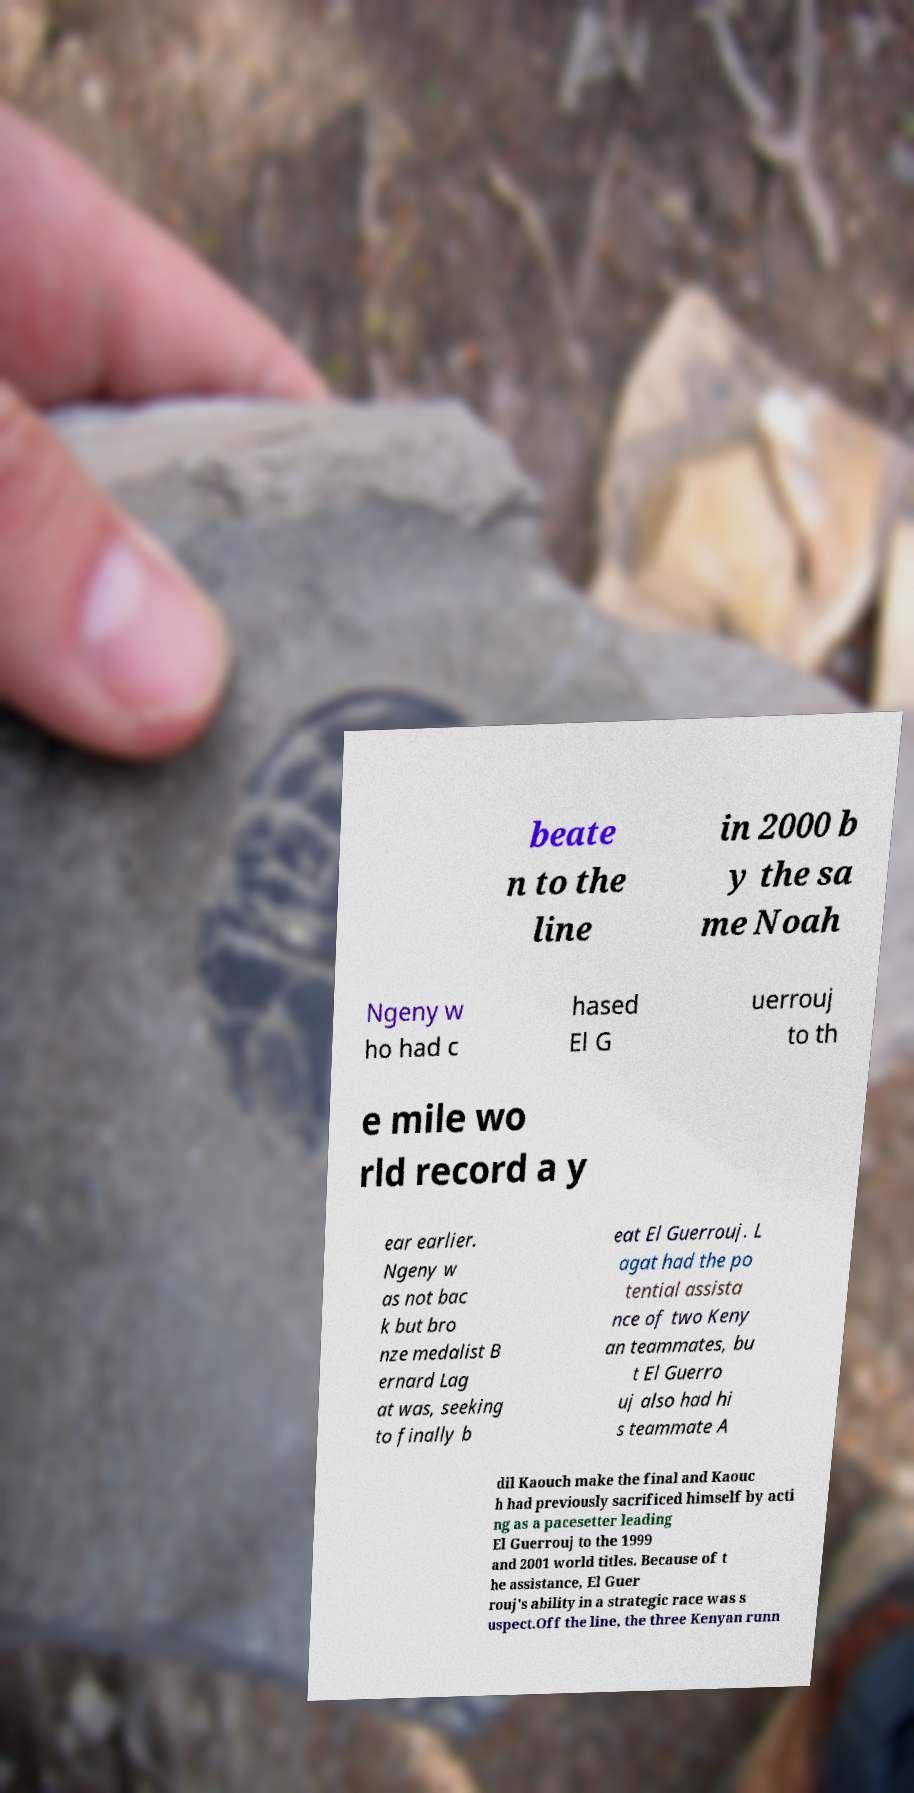Can you read and provide the text displayed in the image?This photo seems to have some interesting text. Can you extract and type it out for me? beate n to the line in 2000 b y the sa me Noah Ngeny w ho had c hased El G uerrouj to th e mile wo rld record a y ear earlier. Ngeny w as not bac k but bro nze medalist B ernard Lag at was, seeking to finally b eat El Guerrouj. L agat had the po tential assista nce of two Keny an teammates, bu t El Guerro uj also had hi s teammate A dil Kaouch make the final and Kaouc h had previously sacrificed himself by acti ng as a pacesetter leading El Guerrouj to the 1999 and 2001 world titles. Because of t he assistance, El Guer rouj's ability in a strategic race was s uspect.Off the line, the three Kenyan runn 